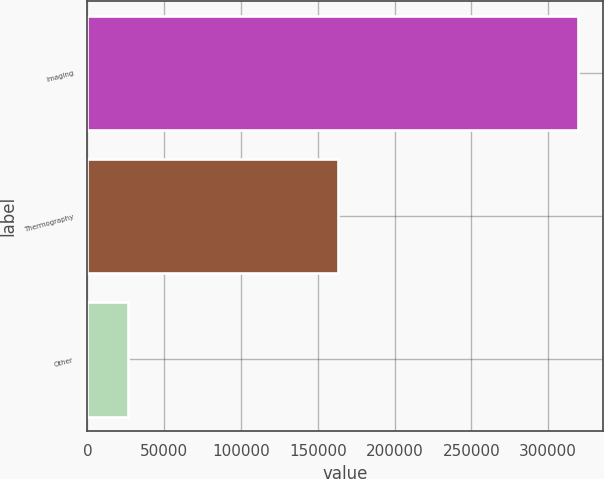<chart> <loc_0><loc_0><loc_500><loc_500><bar_chart><fcel>Imaging<fcel>Thermography<fcel>Other<nl><fcel>319509<fcel>163142<fcel>26107<nl></chart> 